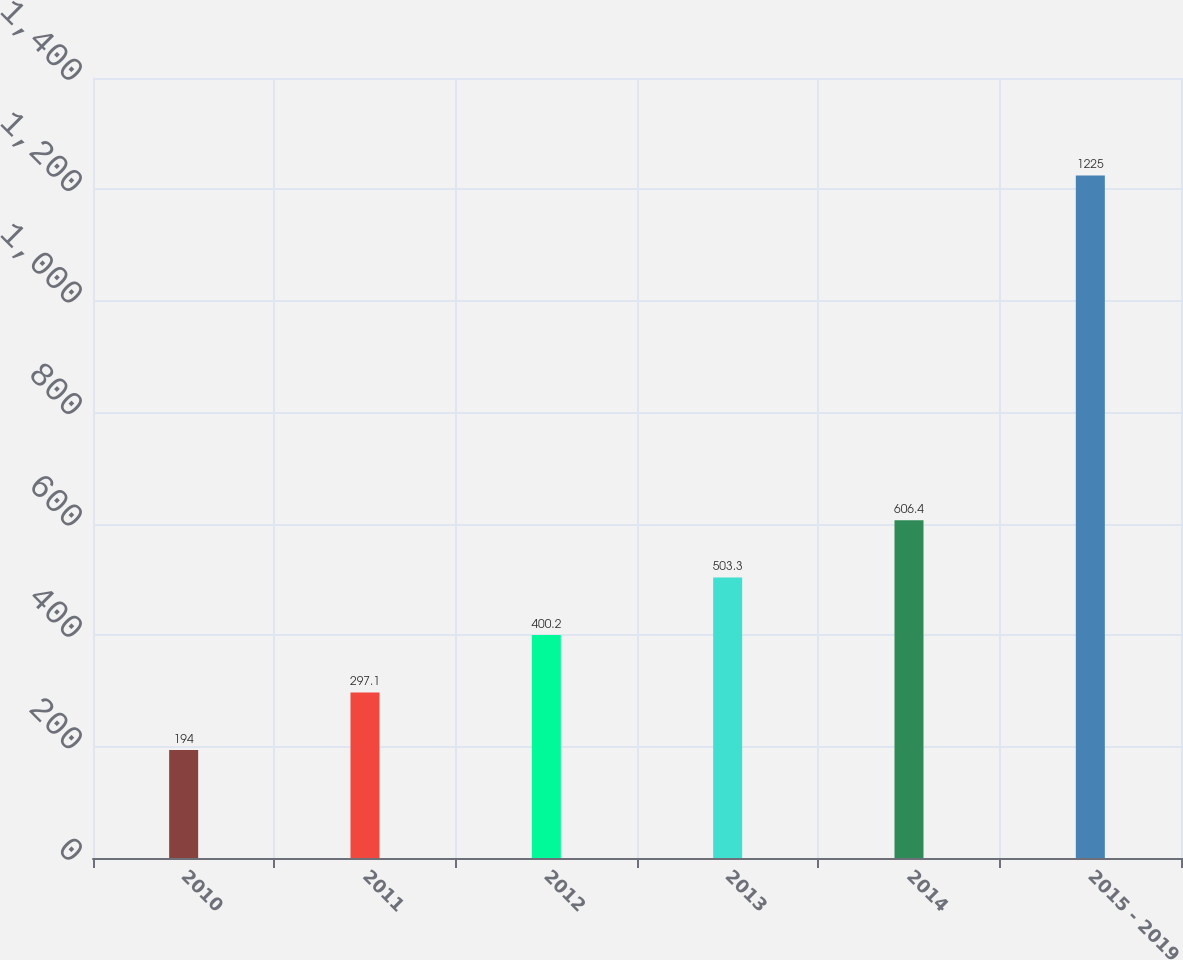<chart> <loc_0><loc_0><loc_500><loc_500><bar_chart><fcel>2010<fcel>2011<fcel>2012<fcel>2013<fcel>2014<fcel>2015 - 2019<nl><fcel>194<fcel>297.1<fcel>400.2<fcel>503.3<fcel>606.4<fcel>1225<nl></chart> 